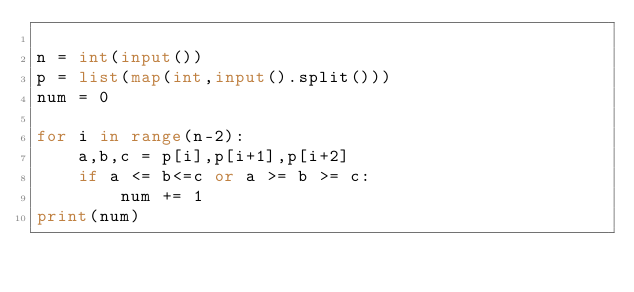Convert code to text. <code><loc_0><loc_0><loc_500><loc_500><_Python_>
n = int(input())
p = list(map(int,input().split()))
num = 0

for i in range(n-2):
    a,b,c = p[i],p[i+1],p[i+2]
    if a <= b<=c or a >= b >= c:
        num += 1
print(num)



</code> 